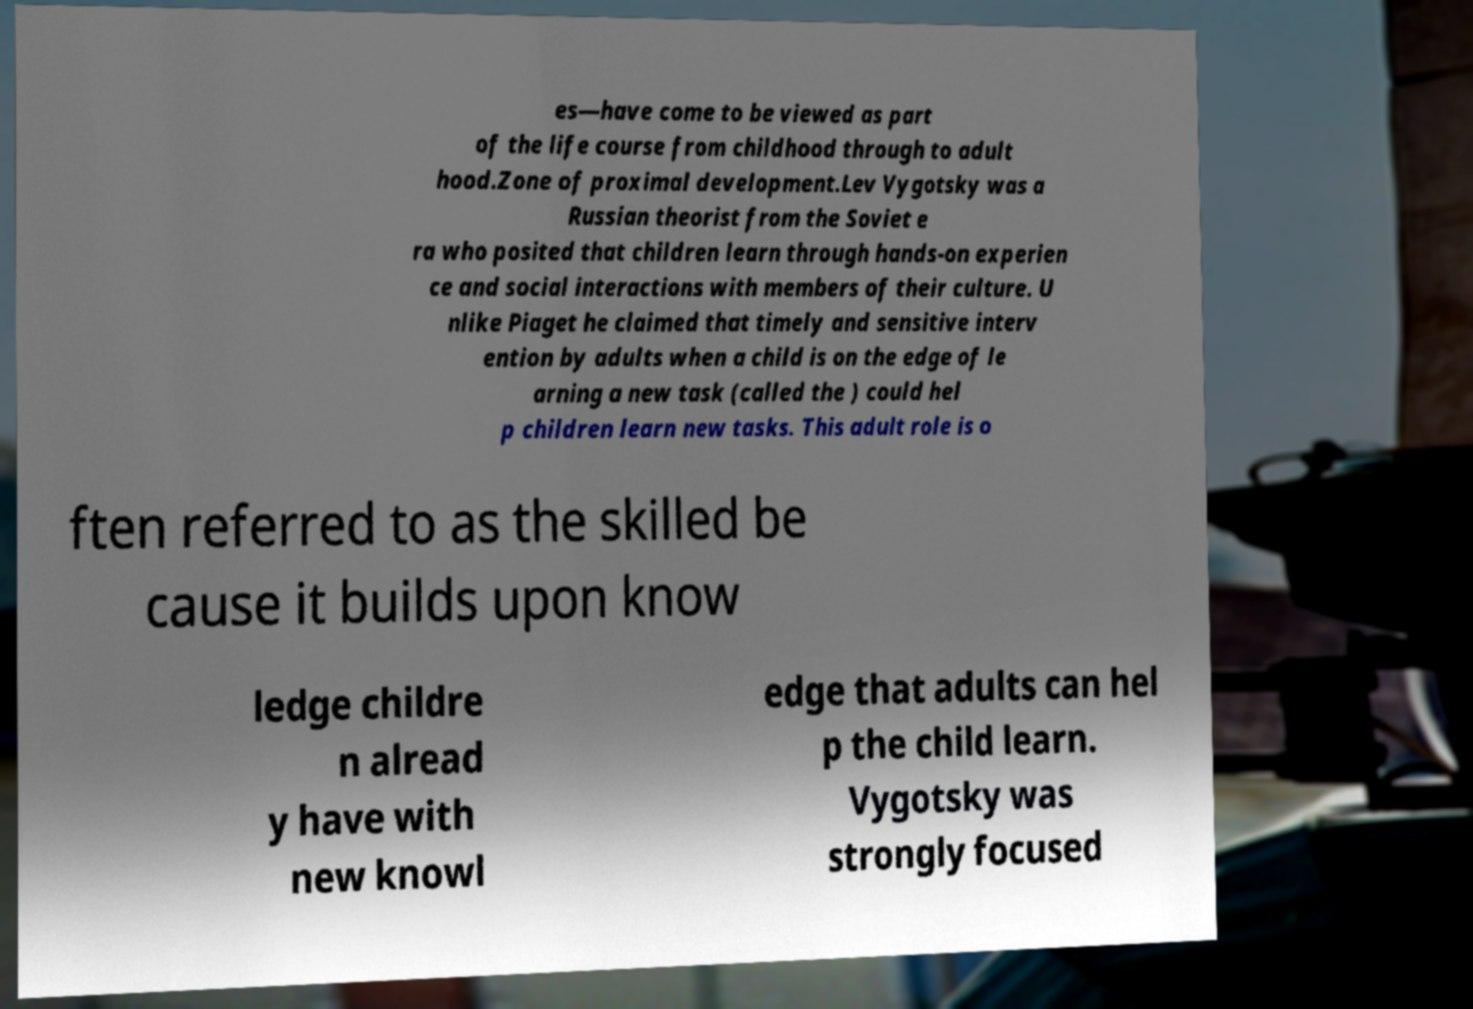I need the written content from this picture converted into text. Can you do that? es—have come to be viewed as part of the life course from childhood through to adult hood.Zone of proximal development.Lev Vygotsky was a Russian theorist from the Soviet e ra who posited that children learn through hands-on experien ce and social interactions with members of their culture. U nlike Piaget he claimed that timely and sensitive interv ention by adults when a child is on the edge of le arning a new task (called the ) could hel p children learn new tasks. This adult role is o ften referred to as the skilled be cause it builds upon know ledge childre n alread y have with new knowl edge that adults can hel p the child learn. Vygotsky was strongly focused 